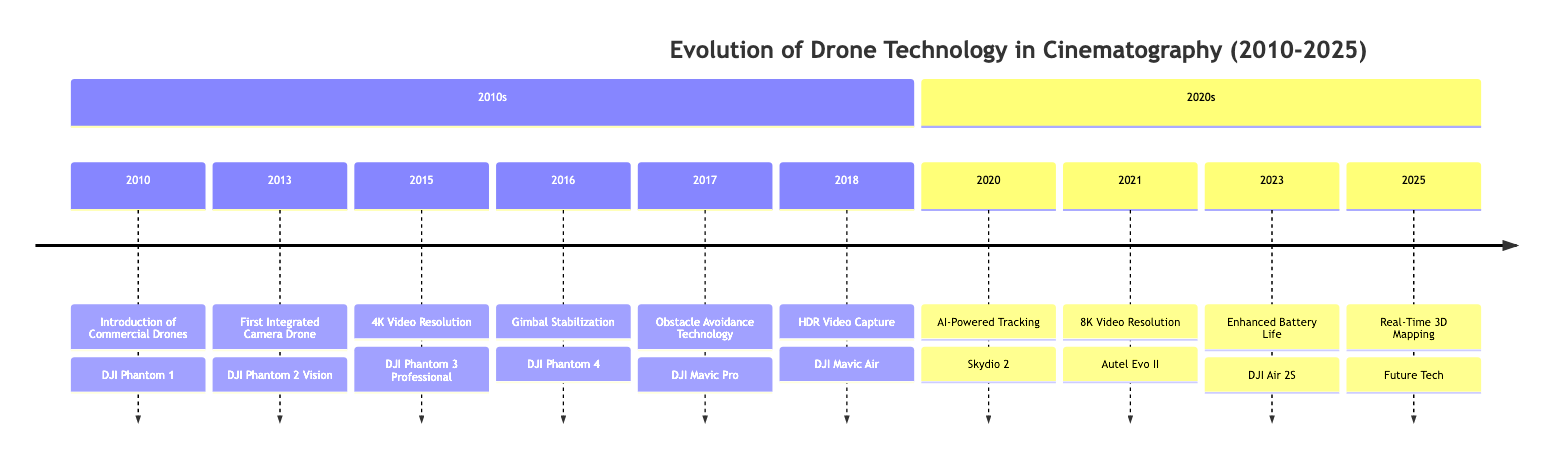What was the first commercial drone introduced? According to the timeline, the first commercial drone introduced was the DJI Phantom 1 in 2010.
Answer: DJI Phantom 1 Which year marked the introduction of integrated cameras in drones? The timeline shows that the first integrated camera drone, the DJI Phantom 2 Vision, was released in 2013.
Answer: 2013 How many major milestones in drone technology occurred between 2010 and 2025? By counting the events listed in the timeline, there are ten major milestones from 2010 to 2025.
Answer: 10 What significant advancement came with the DJI Phantom 3 Professional? The timeline states that the DJI Phantom 3 Professional introduced 4K video resolution in 2015, enhancing video quality.
Answer: 4K video resolution Which drone introduced AI-powered tracking technology? The timeline indicates that AI-powered tracking was introduced with the Skydio 2 in 2020.
Answer: Skydio 2 What feature was included in the DJI Mavic Pro? According to the diagram, the DJI Mavic Pro incorporated obstacle avoidance technology in 2017.
Answer: Obstacle avoidance technology What is expected to be introduced by 2025 regarding aerial videography? The timeline mentions that real-time 3D mapping technology is expected by 2025, which will aid videographers in planning shots.
Answer: Real-time 3D mapping Which drone offers 8K video resolution? As per the timeline, the Autel Evo II is the drone that offers 8K video resolution, introduced in 2021.
Answer: Autel Evo II What year saw the introduction of HDR video capture? The timeline shows that HDR video capture was introduced with the DJI Mavic Air in 2018.
Answer: 2018 